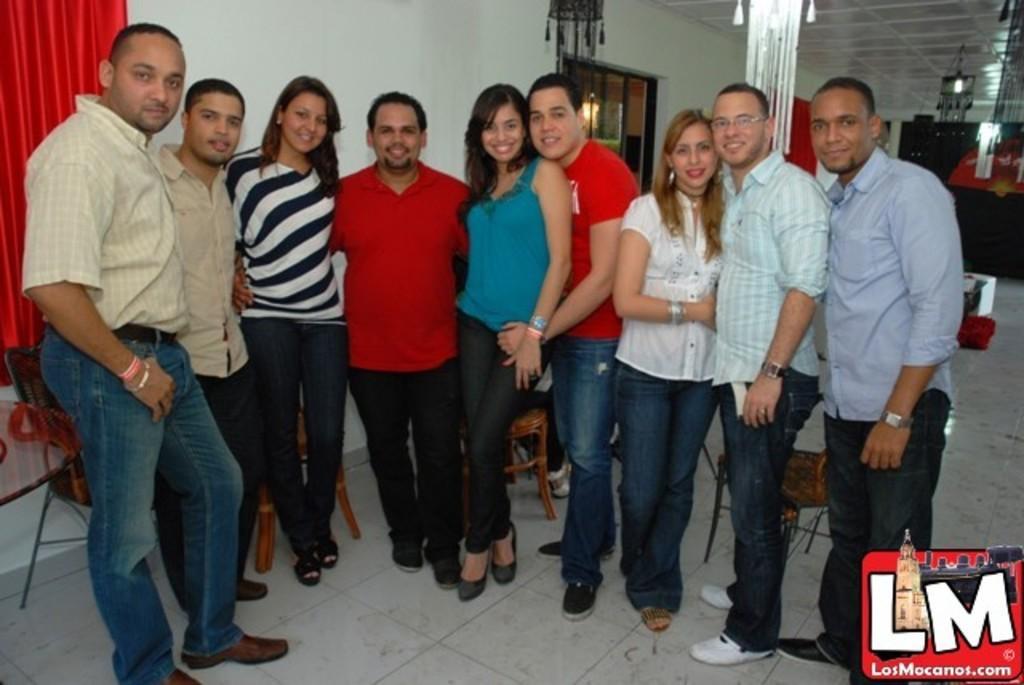Could you give a brief overview of what you see in this image? In this image in the foreground there are some people who are standing and some of them are smiling. At the bottom there is a floor and in the background there are some chairs and wall, windows and curtains. On the top of the image there is a chandelier, on the right side there are some boards and boxes and one light. 